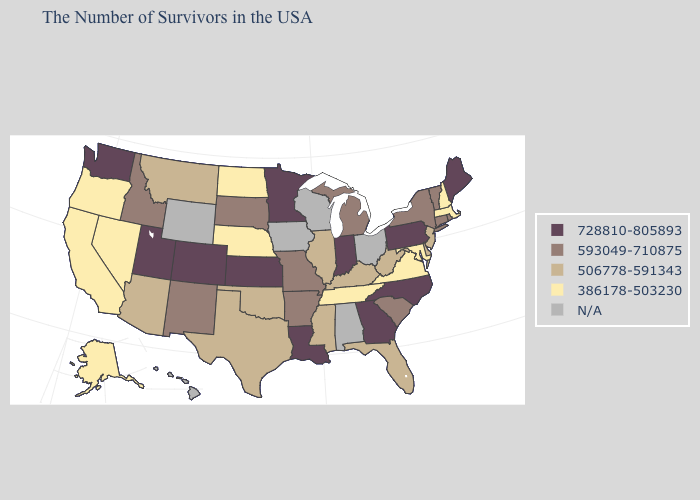What is the highest value in states that border Pennsylvania?
Give a very brief answer. 593049-710875. Does the first symbol in the legend represent the smallest category?
Quick response, please. No. Which states have the lowest value in the South?
Keep it brief. Maryland, Virginia, Tennessee. Name the states that have a value in the range 728810-805893?
Keep it brief. Maine, Pennsylvania, North Carolina, Georgia, Indiana, Louisiana, Minnesota, Kansas, Colorado, Utah, Washington. Name the states that have a value in the range 506778-591343?
Give a very brief answer. New Jersey, Delaware, West Virginia, Florida, Kentucky, Illinois, Mississippi, Oklahoma, Texas, Montana, Arizona. Does North Carolina have the highest value in the South?
Concise answer only. Yes. What is the highest value in the West ?
Write a very short answer. 728810-805893. What is the value of Alaska?
Short answer required. 386178-503230. What is the highest value in the West ?
Give a very brief answer. 728810-805893. Does Connecticut have the lowest value in the Northeast?
Write a very short answer. No. What is the highest value in the USA?
Concise answer only. 728810-805893. Which states hav the highest value in the Northeast?
Be succinct. Maine, Pennsylvania. What is the value of Hawaii?
Give a very brief answer. N/A. What is the value of Arkansas?
Give a very brief answer. 593049-710875. 